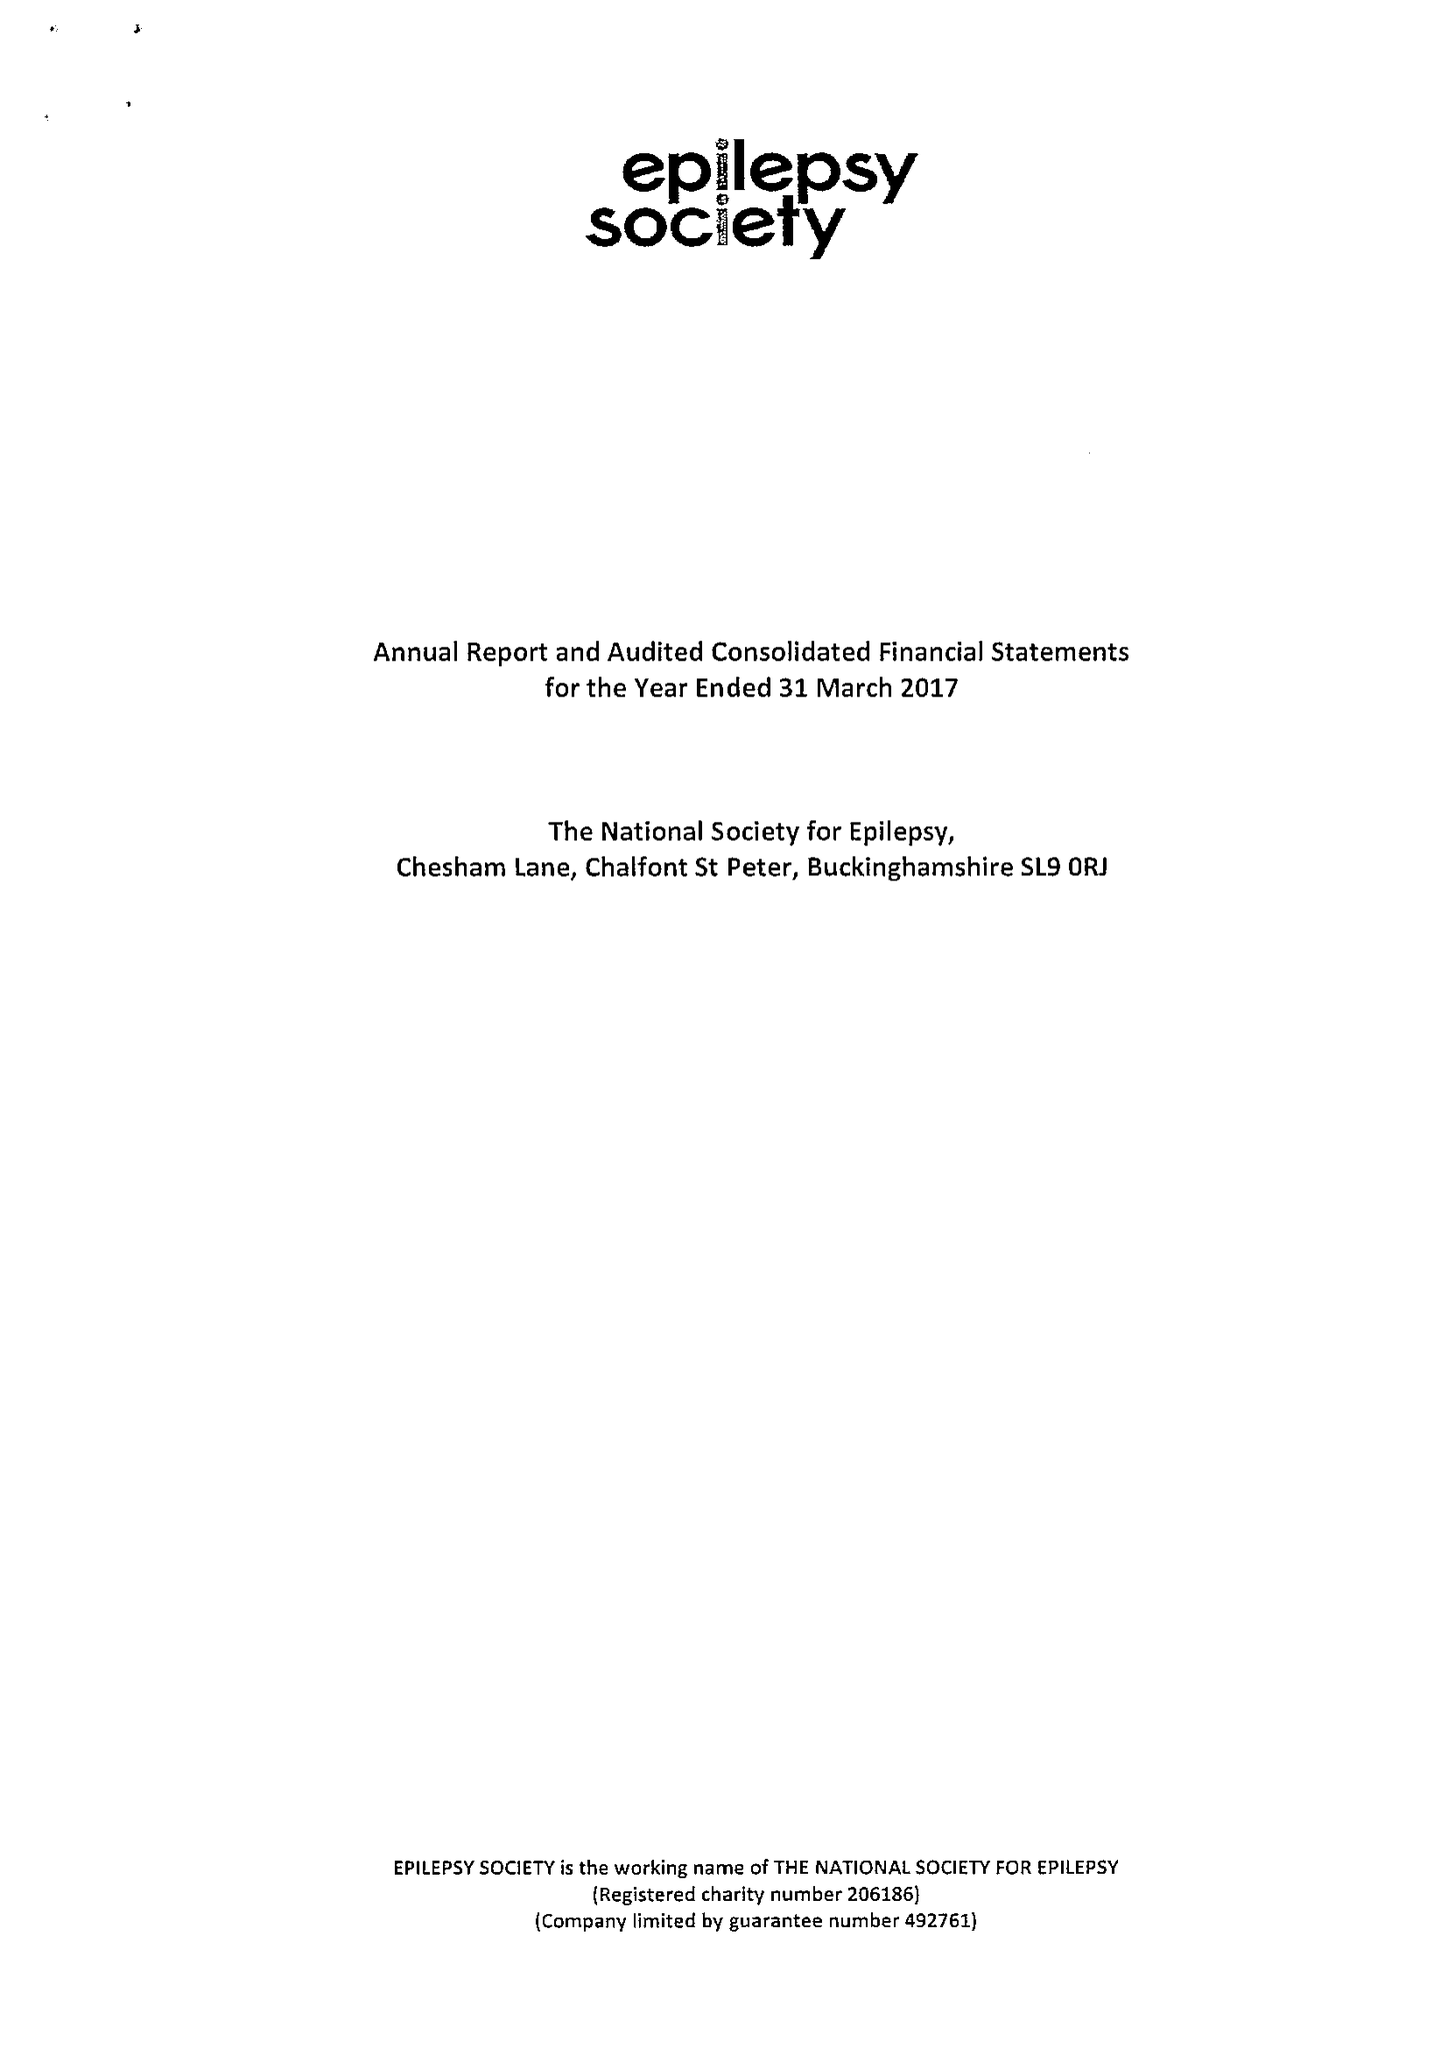What is the value for the address__street_line?
Answer the question using a single word or phrase. CHESHAM LANE 